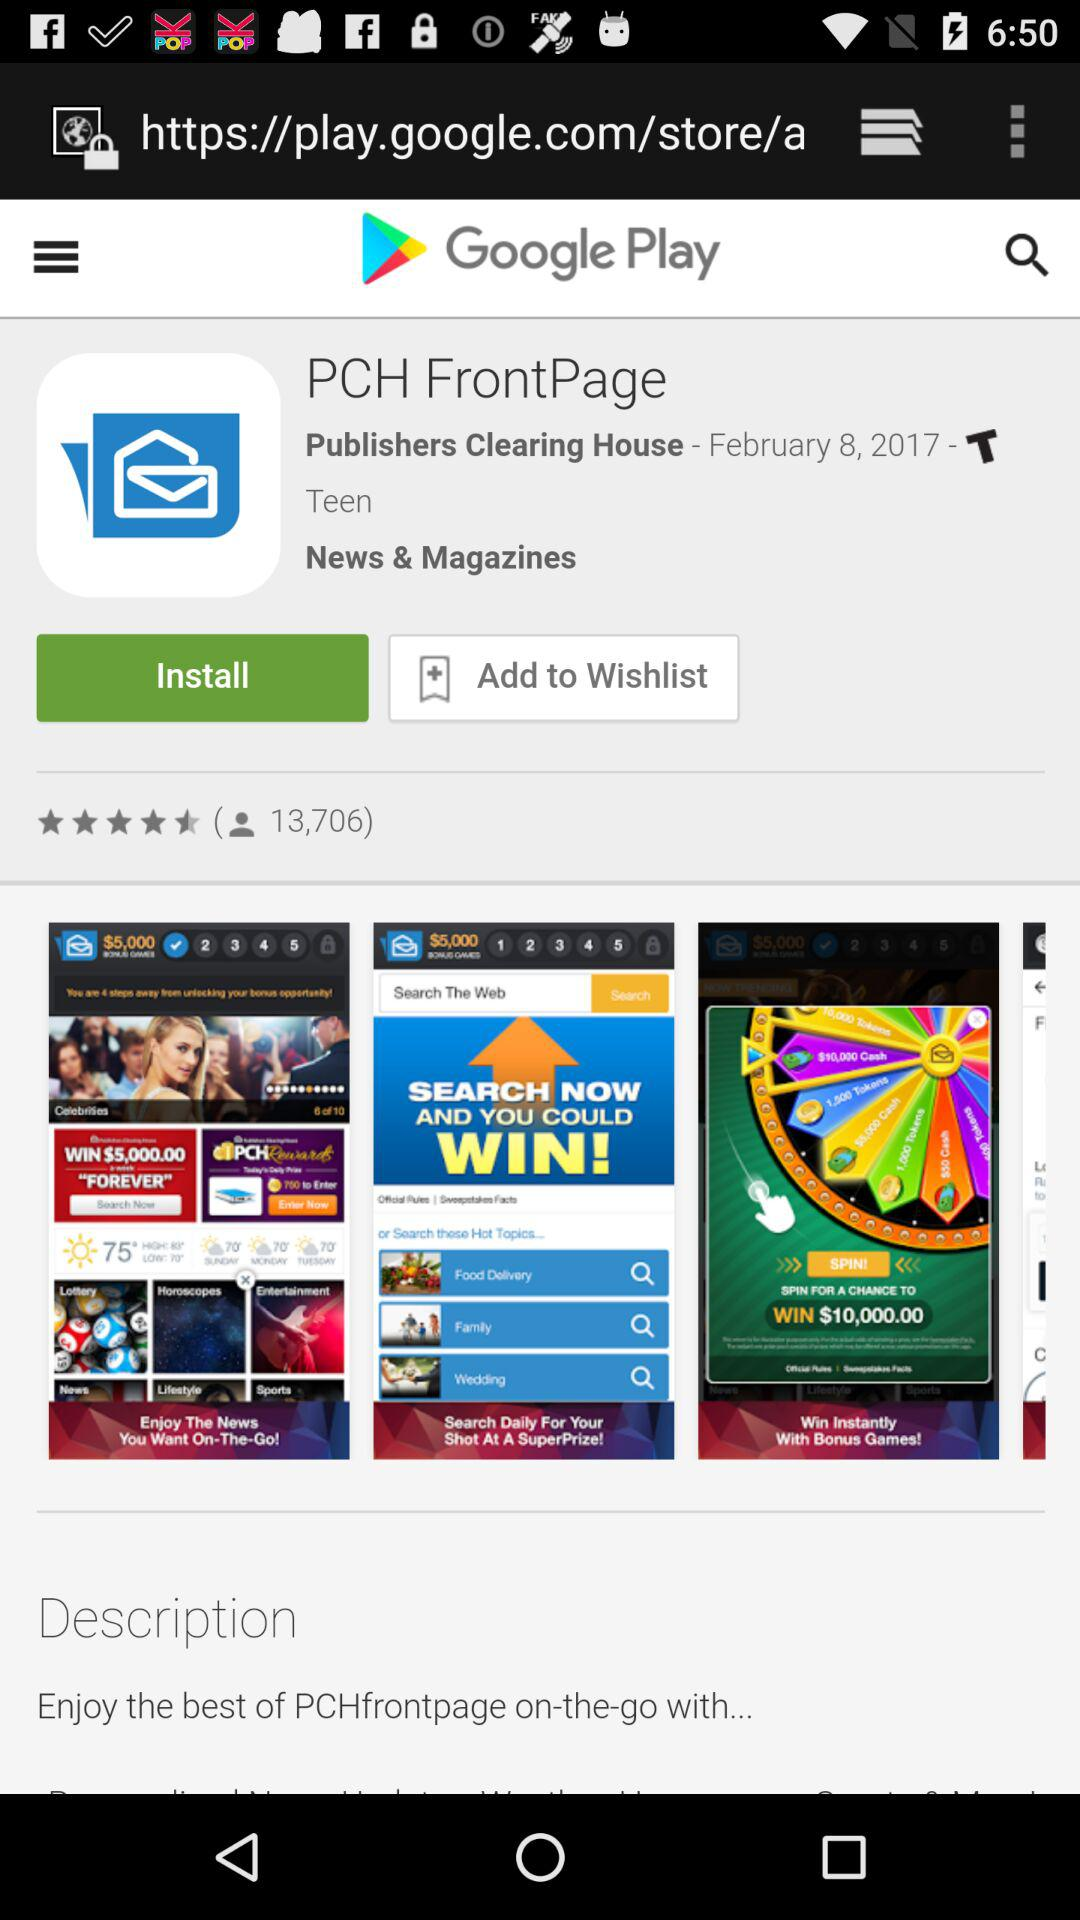How many people have reviewed the app? The number of people that have reviewed the app is 13,706. 